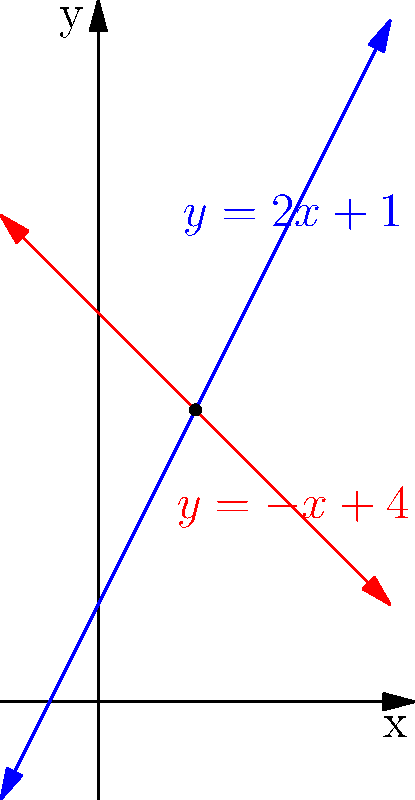As an art therapy student interested in community engagement, you're designing a visual exercise to help clients understand the concept of intersecting life paths. To create this exercise, you need to find the intersection point of two lines represented by the equations $y = 2x + 1$ and $y = -x + 4$. Determine the coordinates of the intersection point. To find the intersection point, we need to solve the system of equations:

1) $y = 2x + 1$
2) $y = -x + 4$

Step 1: Since both equations are equal to $y$, we can set them equal to each other:
$2x + 1 = -x + 4$

Step 2: Add $x$ to both sides:
$3x + 1 = 4$

Step 3: Subtract 1 from both sides:
$3x = 3$

Step 4: Divide both sides by 3:
$x = 1$

Step 5: Substitute $x = 1$ into either of the original equations. Let's use $y = 2x + 1$:
$y = 2(1) + 1 = 3$

Therefore, the intersection point is $(1, 3)$.
Answer: $(1, 3)$ 